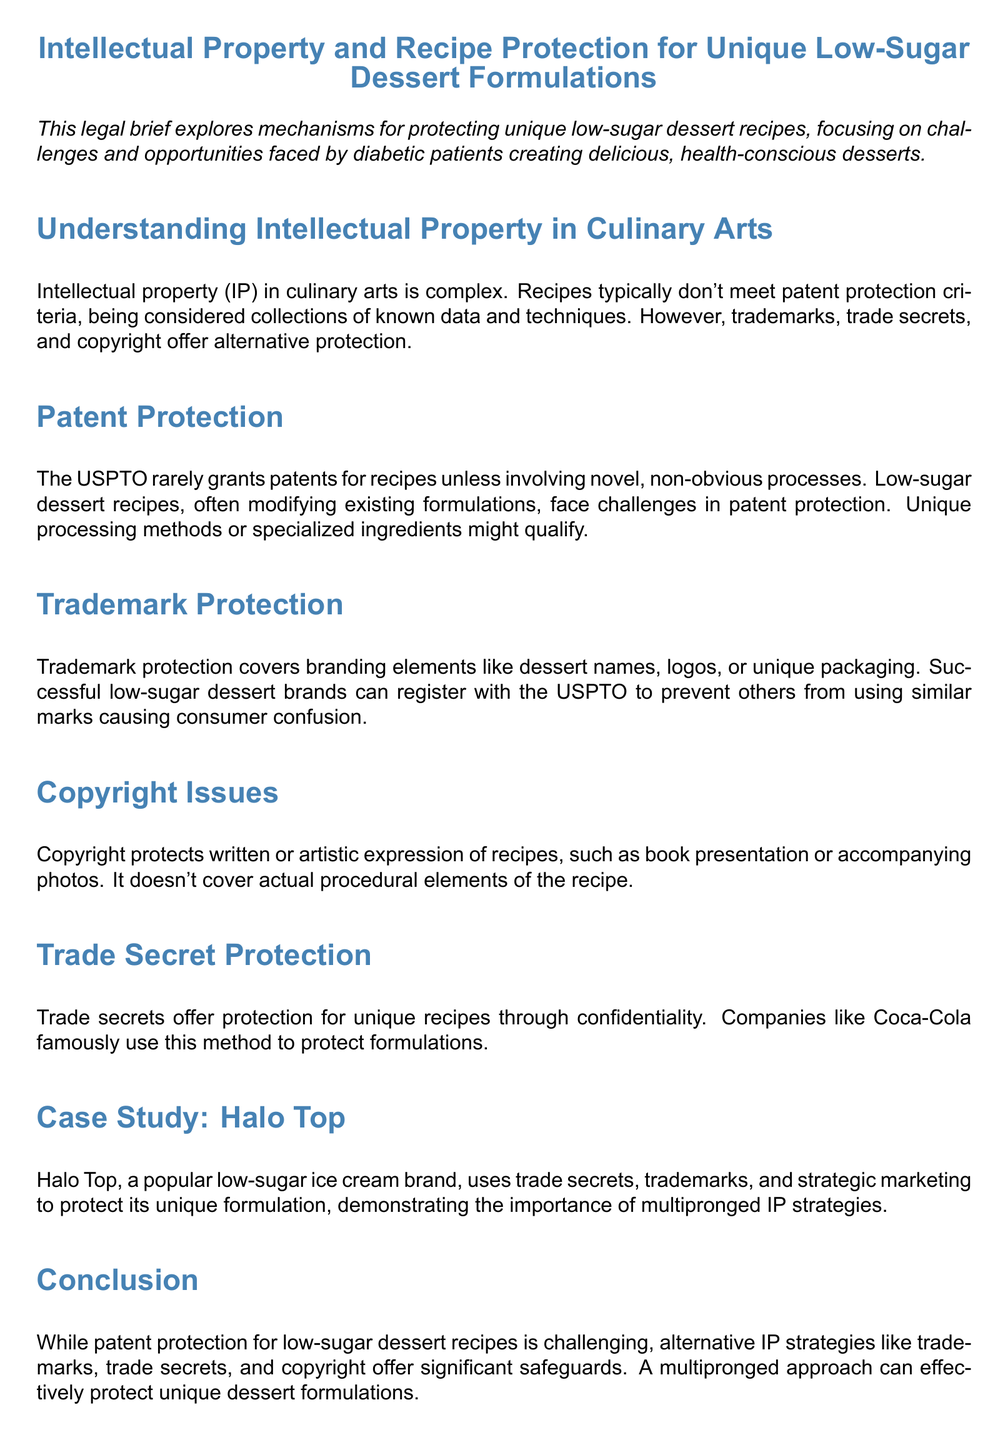what is the focus of the legal brief? The legal brief explores mechanisms for protecting unique low-sugar dessert recipes, focusing on challenges and opportunities faced by diabetic patients creating delicious, health-conscious desserts.
Answer: protecting unique low-sugar dessert recipes what are the alternative protections mentioned for recipes? The document lists trademarks, trade secrets, and copyright as alternative protections for recipes.
Answer: trademarks, trade secrets, and copyright who famously uses trade secret protection? The document mentions Coca-Cola as a company that famously uses trade secret protection for its formulations.
Answer: Coca-Cola what is a significant challenge in patenting recipes? Recipes face challenges in patent protection primarily because they are considered collections of known data and techniques.
Answer: collections of known data and techniques what does copyright protect regarding recipes? Copyright protects the written or artistic expression of recipes, such as book presentation or accompanying photos, but not actual procedural elements.
Answer: written or artistic expression which brand is highlighted as a case study? The case study section highlights Halo Top as a notable example of a low-sugar ice cream brand.
Answer: Halo Top what should one do to protect unique dessert innovations? The document recommends consulting an IP attorney with culinary expertise to devise a comprehensive protection strategy.
Answer: consult an IP attorney what type of protection covers dessert branding elements? Trademark protection covers branding elements like dessert names, logos, or unique packaging.
Answer: trademark protection what is the conclusion about patent protection for low-sugar desserts? The conclusion states that while patent protection for low-sugar dessert recipes is challenging, alternative IP strategies offer significant safeguards.
Answer: challenging 